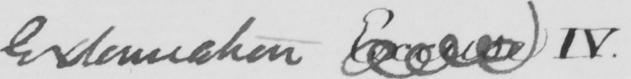What is written in this line of handwriting? Extenuation Excuse IV . 